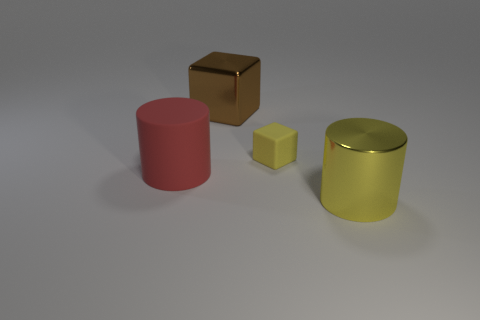Is the yellow cylinder on the right larger in volume than the red cylinder? Judging visually from the image, the yellow cylinder on the right does appear to be larger in volume compared to the red cylinder, as it seems to have both a greater height and diameter. 